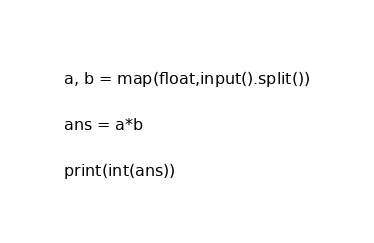<code> <loc_0><loc_0><loc_500><loc_500><_Python_>a, b = map(float,input().split())

ans = a*b

print(int(ans))</code> 